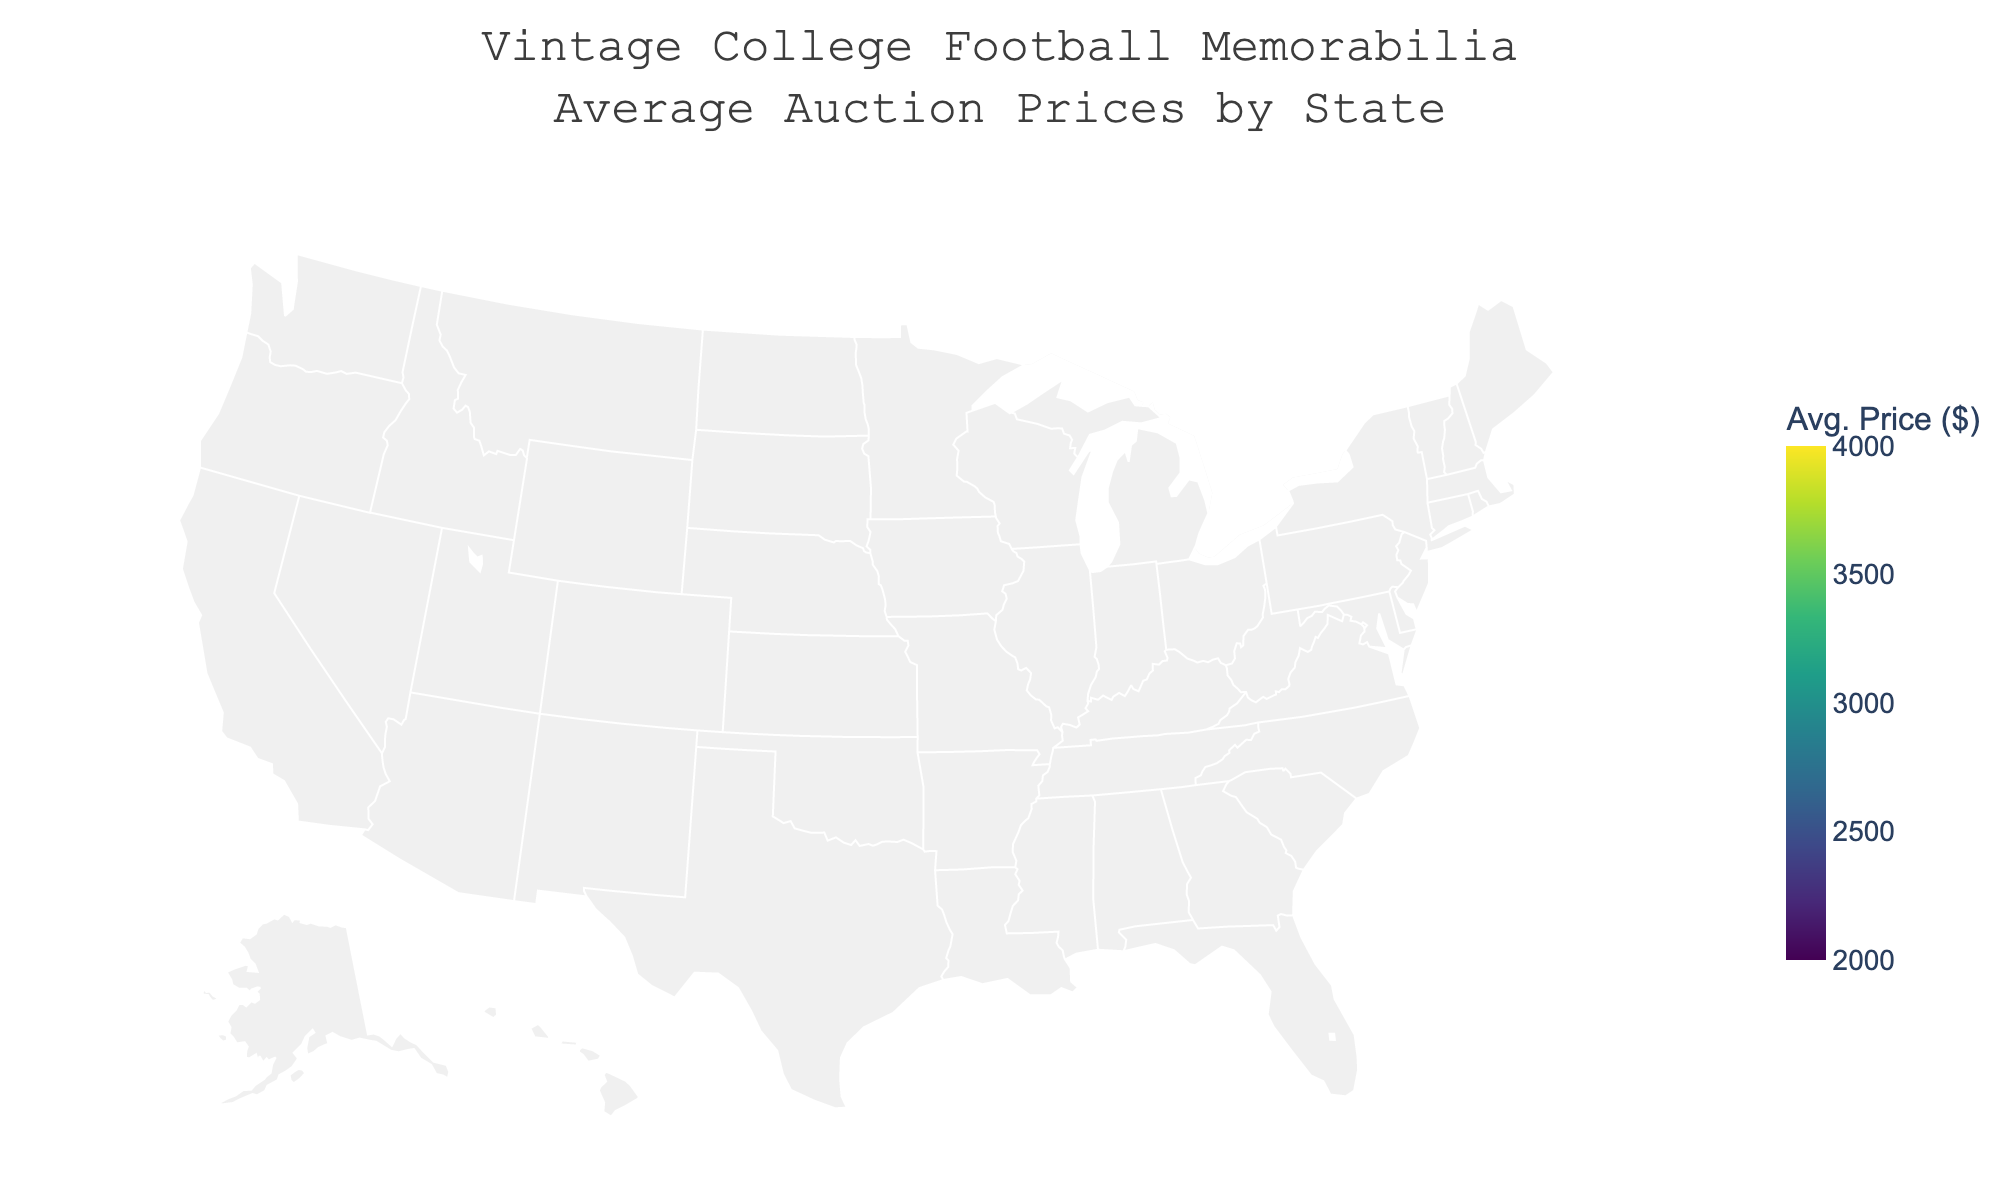What's the title of the figure? The title is displayed at the top of the figure and usually provides a concise description. Here, it reads 'Vintage College Football Memorabilia Average Auction Prices by State'.
Answer: Vintage College Football Memorabilia Average Auction Prices by State What color scale is used in the figure? Observing the color scheme, you can see it transitions through shades of green and purple, which is characteristic of the Viridis color scale.
Answer: Viridis Which state has the highest average auction price for memorabilia? By looking at the color intensity and referring to the annotations, Ohio has the highest average auction price of $3800.
Answer: Ohio Which states have an average auction price greater than $3300? By examining the color intensities and confirming with annotations, Georgia ($3400), Tennessee ($3300), Texas ($3700), and Ohio ($3800) are greater than $3300.
Answer: Georgia, Tennessee, Texas, Ohio What's the average auction price range depicted in the color bar on the right? The color bar scale shows the lowest value starting from $2000 and the highest value reaching $4000.
Answer: $2000 - $4000 How does California's average auction price compare to Michigan's? Referring to the annotations, California has an average price of $2800, while Michigan's is $3600, which means Michigan's is $800 higher.
Answer: Michigan's is $800 higher What's the sum of the average auction prices for New York and Texas? New York has an average price of $2700 and Texas has $3700. Summing them gives $2700 + $3700 = $6400.
Answer: $6400 Which state falls within the $2500 to $2700 auction price range? Observing the annotations and colors, Illinois ($2600), Nebraska ($2500), and New York ($2700) fall within this range.
Answer: Illinois, Nebraska, New York What's the difference between the lowest and highest average auction prices? The lowest price is from Iowa ($2300) and the highest is from Ohio ($3800). The difference is $3800 - $2300 = $1500.
Answer: $1500 How do states in the southeastern US compare in terms of average auction prices? Focusing on states like Florida ($3100), Georgia ($3400), Tennessee ($3300), Alabama ($3250), and Louisiana ($2900), they all have relatively high average prices, with Georgia having the highest and Louisiana the lowest.
Answer: They have relatively high average prices, with Georgia highest and Louisiana lowest 